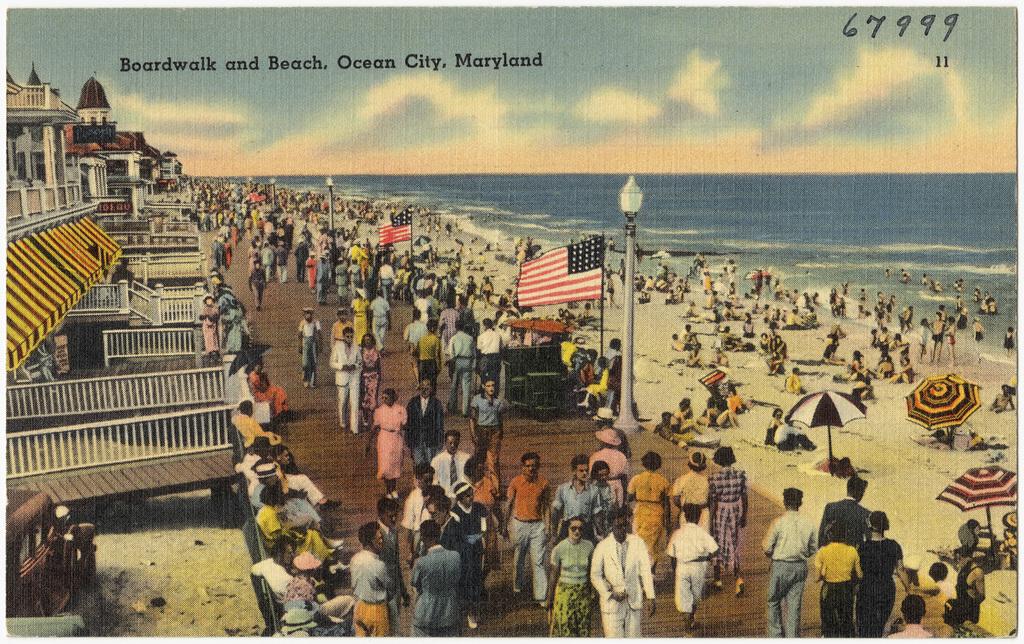What number is this post card?
Offer a terse response. 67999. Where is this postcard from?
Your answer should be compact. Ocean city, maryland. 